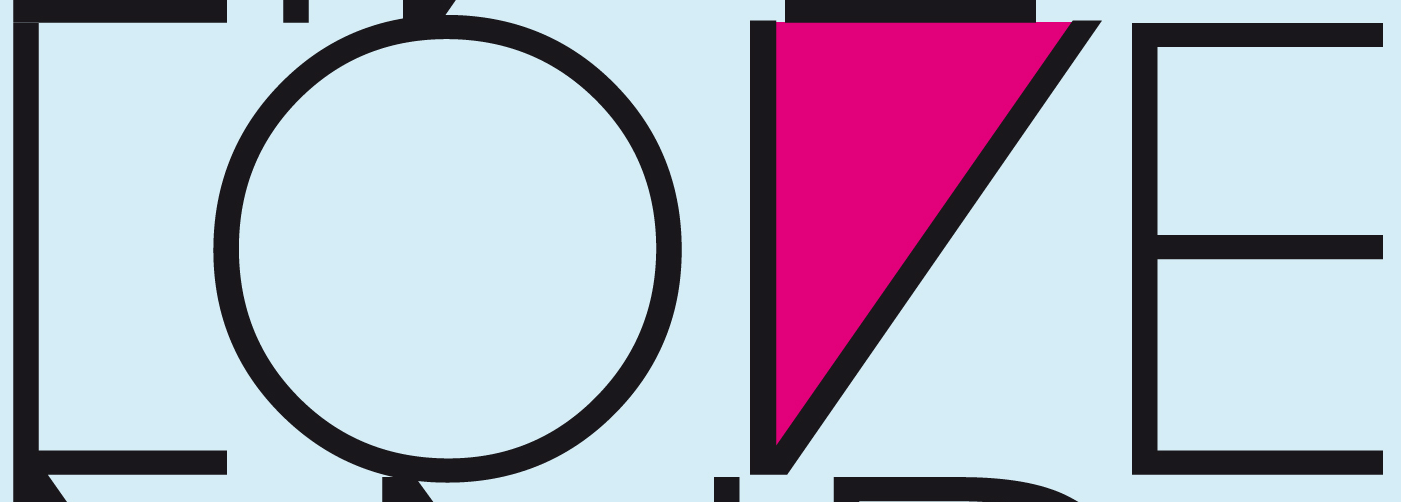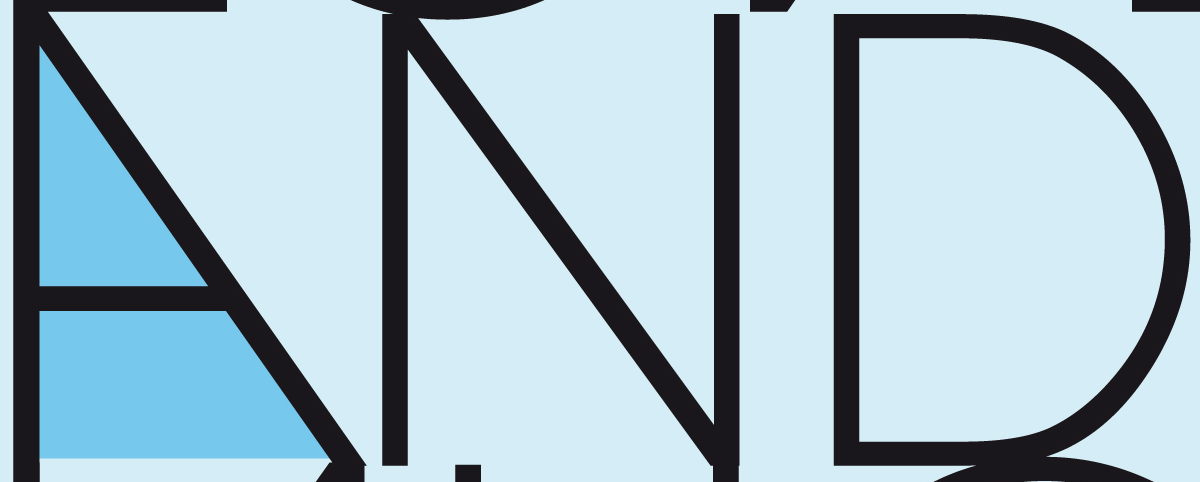Transcribe the words shown in these images in order, separated by a semicolon. LOVE; AND 